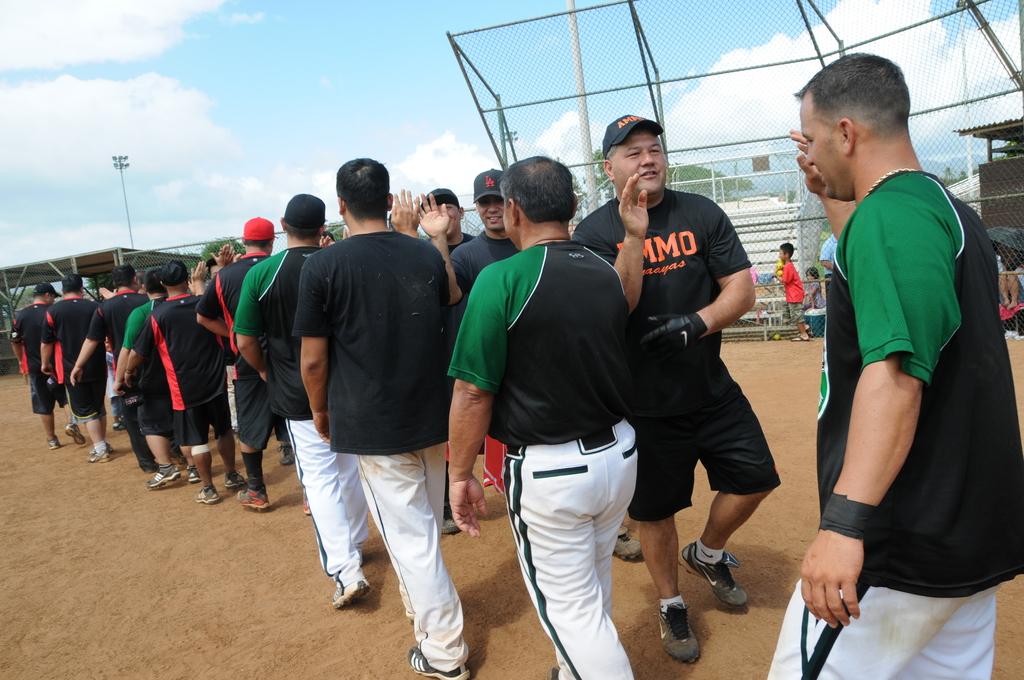What is the last orange letter on the man's shirt?
Provide a succinct answer. O. 